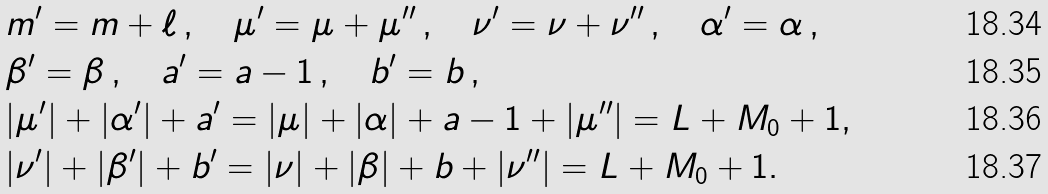<formula> <loc_0><loc_0><loc_500><loc_500>& m ^ { \prime } = m + \ell \, , \quad \mu ^ { \prime } = \mu + \mu ^ { \prime \prime } \, , \quad \nu ^ { \prime } = \nu + \nu ^ { \prime \prime } \, , \quad \alpha ^ { \prime } = \alpha \, , \\ & \beta ^ { \prime } = \beta \, , \quad a ^ { \prime } = a - 1 \, , \quad b ^ { \prime } = b \, , \\ & | \mu ^ { \prime } | + | \alpha ^ { \prime } | + a ^ { \prime } = | \mu | + | \alpha | + a - 1 + | \mu ^ { \prime \prime } | = L + M _ { 0 } + 1 , \\ & | \nu ^ { \prime } | + | \beta ^ { \prime } | + b ^ { \prime } = | \nu | + | \beta | + b + | \nu ^ { \prime \prime } | = L + M _ { 0 } + 1 .</formula> 